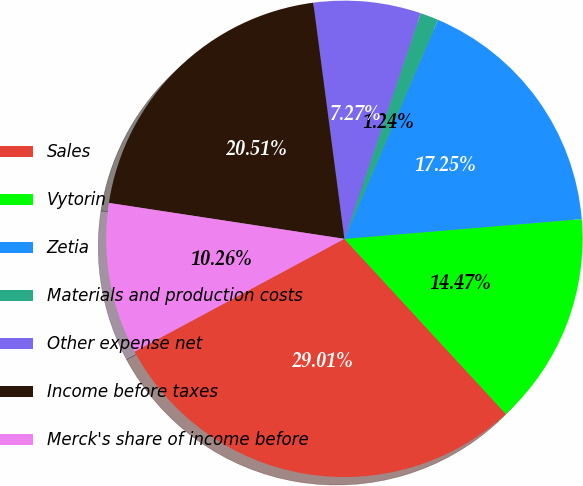Convert chart to OTSL. <chart><loc_0><loc_0><loc_500><loc_500><pie_chart><fcel>Sales<fcel>Vytorin<fcel>Zetia<fcel>Materials and production costs<fcel>Other expense net<fcel>Income before taxes<fcel>Merck's share of income before<nl><fcel>29.01%<fcel>14.47%<fcel>17.25%<fcel>1.24%<fcel>7.27%<fcel>20.51%<fcel>10.26%<nl></chart> 